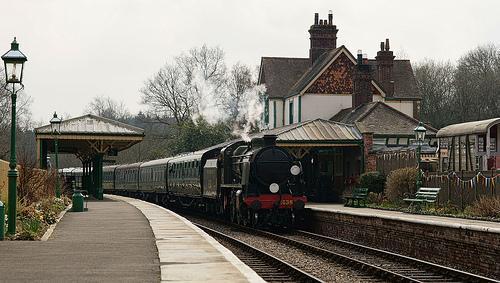How many trains are in this picture?
Give a very brief answer. 1. 